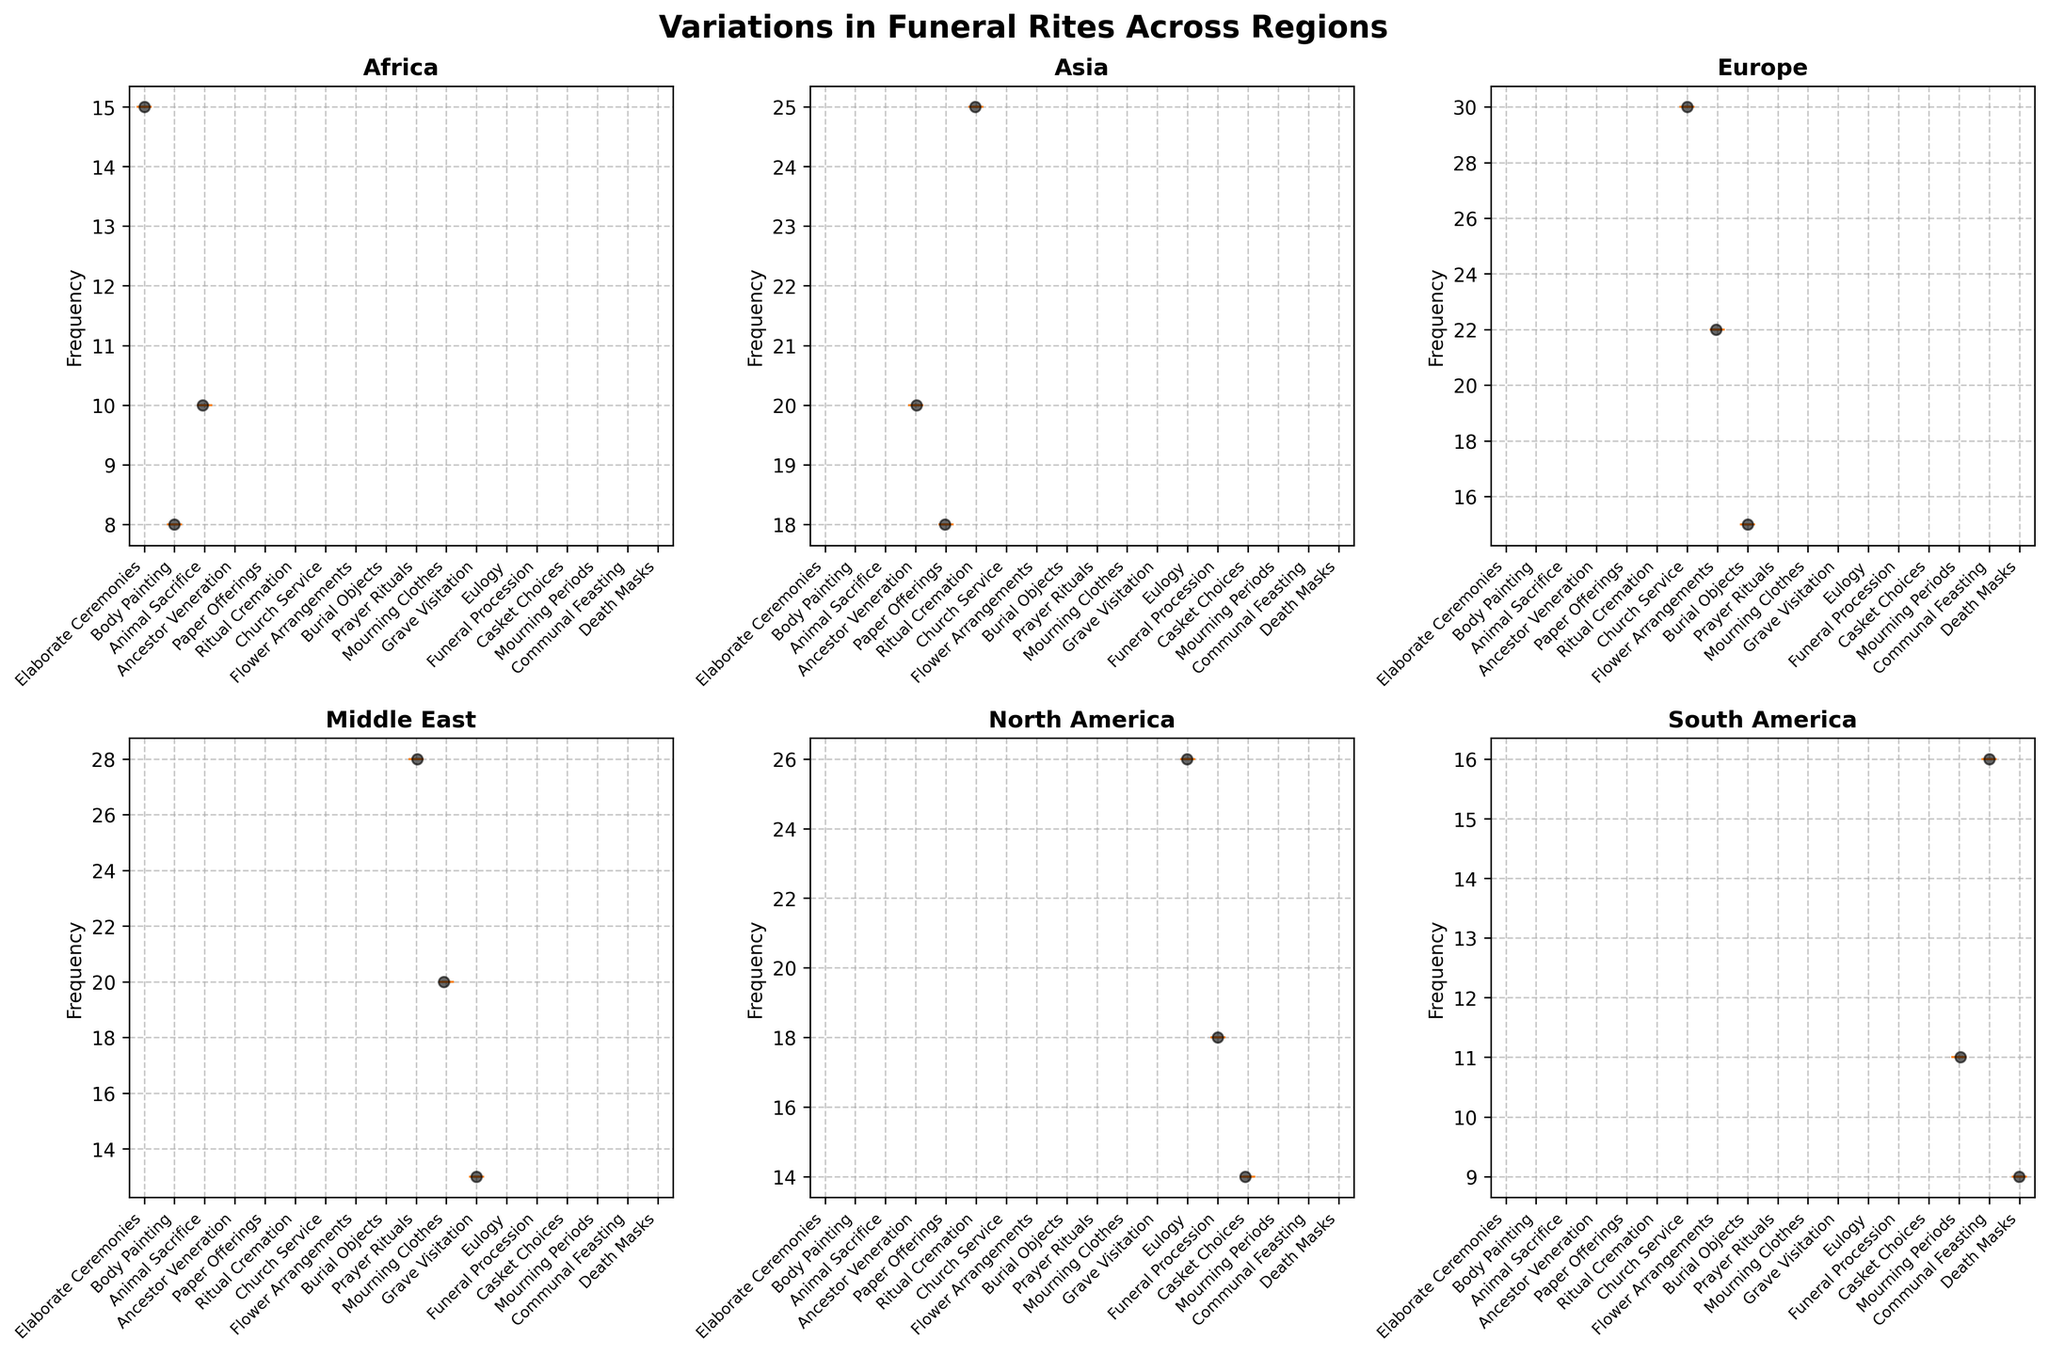What is the title of the figure? The title of the figure is typically located at the top center. The figure shows "Variations in Funeral Rites Across Regions."
Answer: Variations in Funeral Rites Across Regions What does the y-axis represent in the box plots? The y-axis typically shows the variable measured. In this figure, it represents the "Frequency" of different funeral rites.
Answer: Frequency Which region shows the highest maximum frequency for any rite? To determine this, look for the highest data point across all regional subplots. The highest max value is found in the Europe plot for "Church Service."
Answer: Europe How many regions are depicted in the plot? Each subplot represents a different region. There are subplots for Africa, Asia, Europe, Middle East, North America, and South America. Count them.
Answer: 6 In the Africa subplot, which rite has the widest range of frequency values? Check the length of the box plots in the Africa subplot. The rite with the widest range is "Elaborate Ceremonies."
Answer: Elaborate Ceremonies Which region has a rite with the most scattered data points? Look for the subplot where the individual points are most spread out around the box plots. This is most evident in Africa's "Elaborate Ceremonies."
Answer: Africa Compare the median frequency of "Ancestor Veneration" in Asia and the median frequency of "Prayer Rituals" in the Middle East. Which is higher? Locate the median line inside the box plot for each specified rite in their respective regions. The median for "Ancestor Veneration" in Asia is lower than "Prayer Rituals" in the Middle East.
Answer: Middle East Which frequency range is represented by the interquartile range (IQR) in the Europe subplot for "Burial Objects"? The IQR is the range between the first quartile (Q1) and the third quartile (Q3). Look at the box plot for "Burial Objects" in Europe to find this range visually.
Answer: 10 to 20 Does South America show any outliers for any of its rites? Outliers are typically represented by individual points outside the whiskers of a box plot. Check the South America subplot for any such points.
Answer: No What can we infer about the variance in the frequency of funeral rites in North America compared to South America? Variance is indicated by the spread of the box plot and points. North America has a more consistent (less varied) spread compared to South America, indicating lower variance.
Answer: Lower variance in North America 